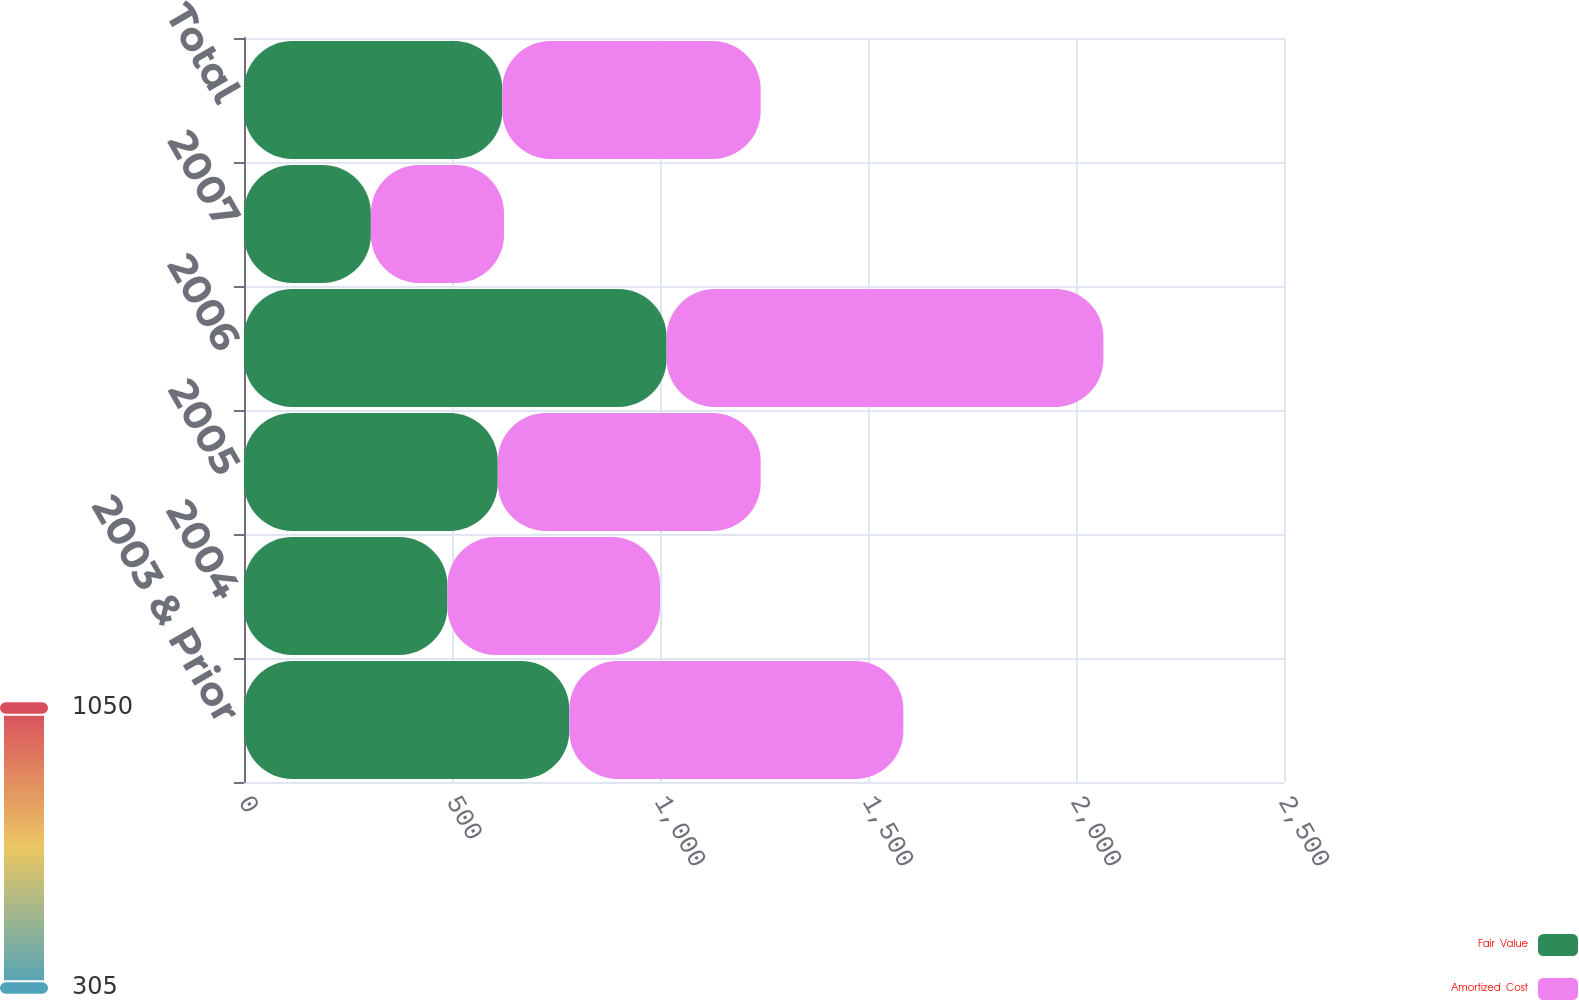Convert chart. <chart><loc_0><loc_0><loc_500><loc_500><stacked_bar_chart><ecel><fcel>2003 & Prior<fcel>2004<fcel>2005<fcel>2006<fcel>2007<fcel>Total<nl><fcel>Fair  Value<fcel>782<fcel>489<fcel>610<fcel>1016<fcel>305<fcel>621<nl><fcel>Amortized  Cost<fcel>803<fcel>511<fcel>632<fcel>1050<fcel>320<fcel>621<nl></chart> 